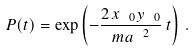<formula> <loc_0><loc_0><loc_500><loc_500>P ( t ) = \exp \left ( - \frac { 2 \, x _ { \ 0 } y _ { \ 0 } } { m a ^ { \ 2 } } \, t \right ) \, .</formula> 